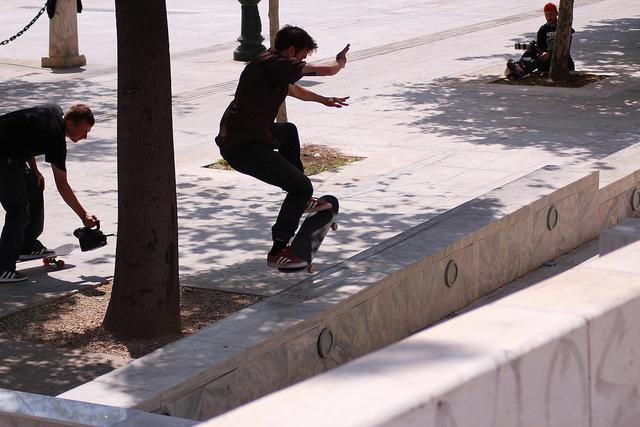What past time is the rightmost person involved in? Please explain your reasoning. photography. The person the right has a camera. 